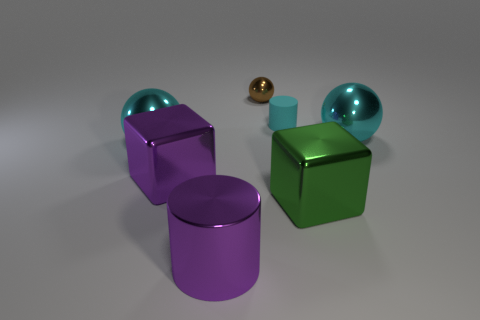Add 3 yellow metal cylinders. How many objects exist? 10 Subtract all cylinders. How many objects are left? 5 Add 3 small cylinders. How many small cylinders are left? 4 Add 3 small things. How many small things exist? 5 Subtract 0 yellow cylinders. How many objects are left? 7 Subtract all shiny cubes. Subtract all brown shiny objects. How many objects are left? 4 